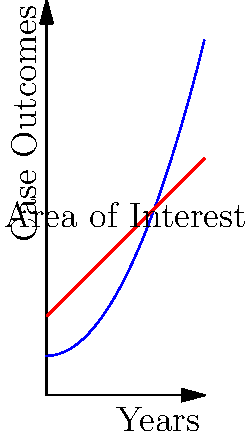The graph shows the trends of favorable legal case outcomes in two countries over a 4-year period. The blue curve represents Country A, and the red line represents Country B. Calculate the difference in the total number of favorable case outcomes between Country A and Country B over the 4-year period, assuming the area under each curve represents the cumulative number of favorable outcomes. Use integral calculus to solve this problem. To solve this problem, we need to calculate the area under each curve and then find the difference. Let's approach this step-by-step:

1. For Country A (blue curve):
   The function appears to be $f(x) = 0.5x^2 + 1$
   We need to integrate this from 0 to 4:
   $$\int_0^4 (0.5x^2 + 1) dx = [0.5 \cdot \frac{x^3}{3} + x]_0^4$$
   $$= (0.5 \cdot \frac{64}{3} + 4) - (0 + 0) = \frac{32}{3} + 4 = \frac{44}{3}$$

2. For Country B (red line):
   The function appears to be $g(x) = x + 2$
   We integrate this from 0 to 4:
   $$\int_0^4 (x + 2) dx = [\frac{x^2}{2} + 2x]_0^4$$
   $$= (\frac{16}{2} + 8) - (0 + 0) = 8 + 8 = 16$$

3. Now we calculate the difference:
   Difference = Area under Country A curve - Area under Country B line
   $$= \frac{44}{3} - 16 = \frac{44}{3} - \frac{48}{3} = -\frac{4}{3}$$

The negative result indicates that Country B had more favorable outcomes overall.
Answer: $-\frac{4}{3}$ 